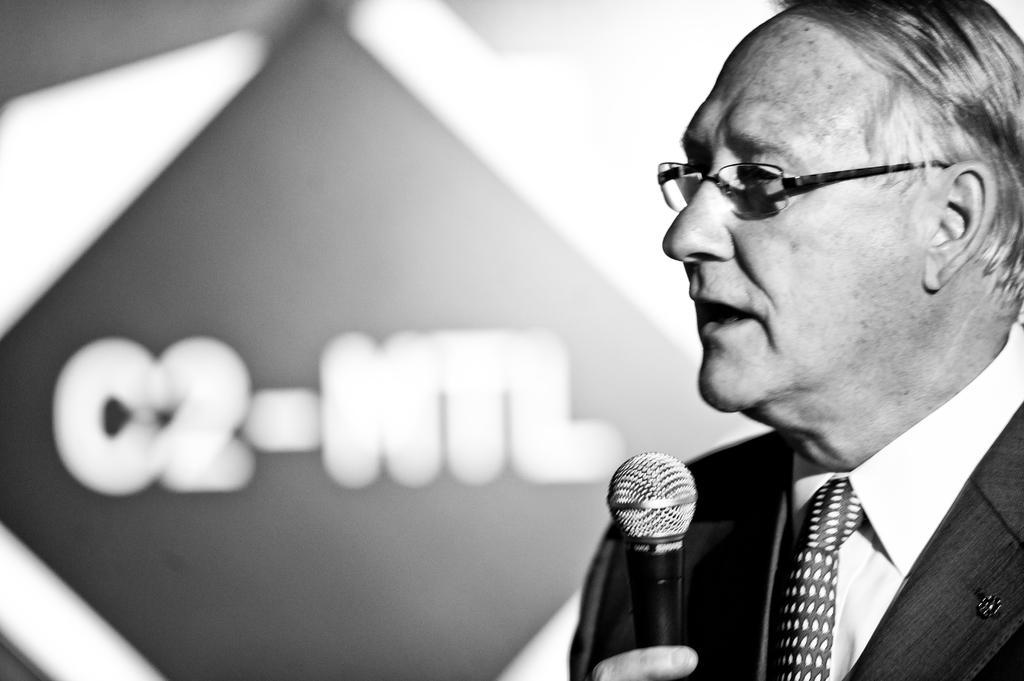Describe this image in one or two sentences. This is a black and white picture. Here is the man standing and holding mike. He is talking. At background this looks like a banner. This man wore suit,tie,shirt and spectacles. 